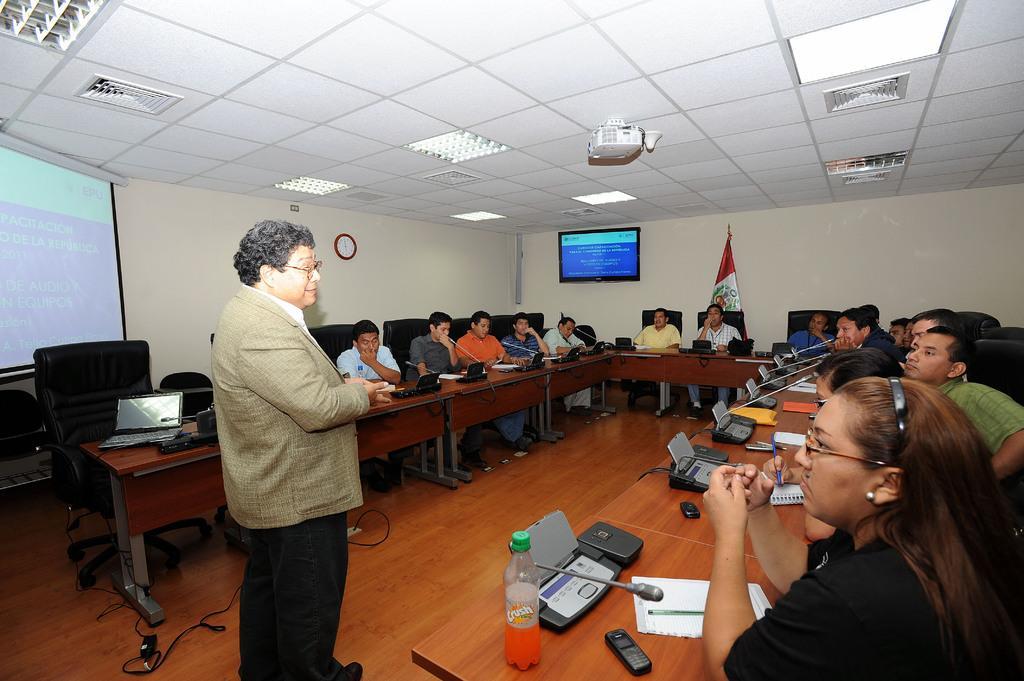Could you give a brief overview of what you see in this image? In this image we can see one person standing, few people sitting on the cars, there are few objects on the table, on the left we can see the projector, we can see the wall and few objects on it, ceiling with lights. 